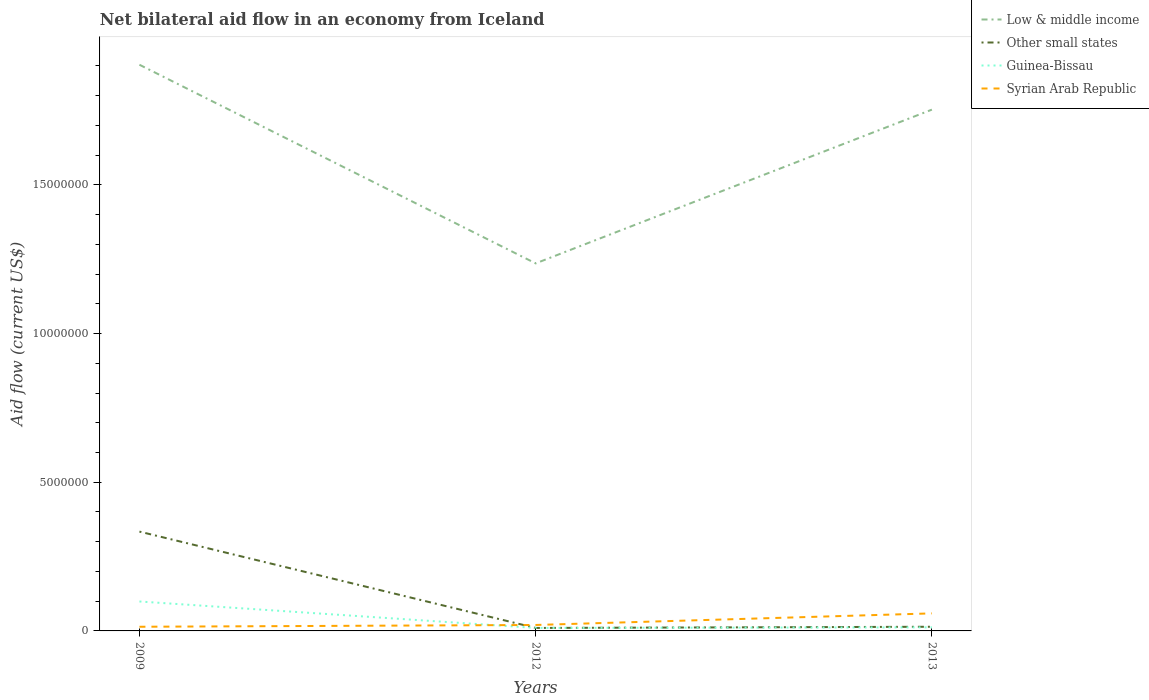How many different coloured lines are there?
Keep it short and to the point. 4. Is the number of lines equal to the number of legend labels?
Offer a very short reply. Yes. Across all years, what is the maximum net bilateral aid flow in Other small states?
Give a very brief answer. 1.00e+05. What is the total net bilateral aid flow in Guinea-Bissau in the graph?
Your response must be concise. 8.70e+05. What is the difference between the highest and the second highest net bilateral aid flow in Other small states?
Your answer should be very brief. 3.24e+06. Is the net bilateral aid flow in Syrian Arab Republic strictly greater than the net bilateral aid flow in Low & middle income over the years?
Offer a very short reply. Yes. How many lines are there?
Your response must be concise. 4. How many years are there in the graph?
Ensure brevity in your answer.  3. What is the title of the graph?
Give a very brief answer. Net bilateral aid flow in an economy from Iceland. Does "Bulgaria" appear as one of the legend labels in the graph?
Keep it short and to the point. No. What is the label or title of the Y-axis?
Your answer should be compact. Aid flow (current US$). What is the Aid flow (current US$) of Low & middle income in 2009?
Keep it short and to the point. 1.90e+07. What is the Aid flow (current US$) in Other small states in 2009?
Give a very brief answer. 3.34e+06. What is the Aid flow (current US$) in Guinea-Bissau in 2009?
Your answer should be very brief. 9.90e+05. What is the Aid flow (current US$) of Syrian Arab Republic in 2009?
Your answer should be very brief. 1.40e+05. What is the Aid flow (current US$) of Low & middle income in 2012?
Offer a terse response. 1.24e+07. What is the Aid flow (current US$) in Other small states in 2012?
Give a very brief answer. 1.00e+05. What is the Aid flow (current US$) in Syrian Arab Republic in 2012?
Your response must be concise. 2.00e+05. What is the Aid flow (current US$) of Low & middle income in 2013?
Your response must be concise. 1.75e+07. What is the Aid flow (current US$) in Guinea-Bissau in 2013?
Make the answer very short. 1.20e+05. What is the Aid flow (current US$) of Syrian Arab Republic in 2013?
Your response must be concise. 5.90e+05. Across all years, what is the maximum Aid flow (current US$) of Low & middle income?
Keep it short and to the point. 1.90e+07. Across all years, what is the maximum Aid flow (current US$) of Other small states?
Your answer should be very brief. 3.34e+06. Across all years, what is the maximum Aid flow (current US$) in Guinea-Bissau?
Your answer should be very brief. 9.90e+05. Across all years, what is the maximum Aid flow (current US$) of Syrian Arab Republic?
Your answer should be compact. 5.90e+05. Across all years, what is the minimum Aid flow (current US$) of Low & middle income?
Your answer should be compact. 1.24e+07. Across all years, what is the minimum Aid flow (current US$) of Other small states?
Keep it short and to the point. 1.00e+05. What is the total Aid flow (current US$) in Low & middle income in the graph?
Offer a terse response. 4.89e+07. What is the total Aid flow (current US$) in Other small states in the graph?
Your answer should be compact. 3.58e+06. What is the total Aid flow (current US$) in Guinea-Bissau in the graph?
Offer a very short reply. 1.21e+06. What is the total Aid flow (current US$) of Syrian Arab Republic in the graph?
Provide a short and direct response. 9.30e+05. What is the difference between the Aid flow (current US$) in Low & middle income in 2009 and that in 2012?
Provide a short and direct response. 6.68e+06. What is the difference between the Aid flow (current US$) in Other small states in 2009 and that in 2012?
Your answer should be compact. 3.24e+06. What is the difference between the Aid flow (current US$) of Guinea-Bissau in 2009 and that in 2012?
Offer a terse response. 8.90e+05. What is the difference between the Aid flow (current US$) in Syrian Arab Republic in 2009 and that in 2012?
Keep it short and to the point. -6.00e+04. What is the difference between the Aid flow (current US$) in Low & middle income in 2009 and that in 2013?
Provide a succinct answer. 1.51e+06. What is the difference between the Aid flow (current US$) of Other small states in 2009 and that in 2013?
Your answer should be very brief. 3.20e+06. What is the difference between the Aid flow (current US$) in Guinea-Bissau in 2009 and that in 2013?
Your response must be concise. 8.70e+05. What is the difference between the Aid flow (current US$) in Syrian Arab Republic in 2009 and that in 2013?
Make the answer very short. -4.50e+05. What is the difference between the Aid flow (current US$) in Low & middle income in 2012 and that in 2013?
Offer a very short reply. -5.17e+06. What is the difference between the Aid flow (current US$) in Syrian Arab Republic in 2012 and that in 2013?
Provide a succinct answer. -3.90e+05. What is the difference between the Aid flow (current US$) in Low & middle income in 2009 and the Aid flow (current US$) in Other small states in 2012?
Make the answer very short. 1.89e+07. What is the difference between the Aid flow (current US$) in Low & middle income in 2009 and the Aid flow (current US$) in Guinea-Bissau in 2012?
Your response must be concise. 1.89e+07. What is the difference between the Aid flow (current US$) of Low & middle income in 2009 and the Aid flow (current US$) of Syrian Arab Republic in 2012?
Offer a terse response. 1.88e+07. What is the difference between the Aid flow (current US$) of Other small states in 2009 and the Aid flow (current US$) of Guinea-Bissau in 2012?
Offer a very short reply. 3.24e+06. What is the difference between the Aid flow (current US$) in Other small states in 2009 and the Aid flow (current US$) in Syrian Arab Republic in 2012?
Your answer should be compact. 3.14e+06. What is the difference between the Aid flow (current US$) of Guinea-Bissau in 2009 and the Aid flow (current US$) of Syrian Arab Republic in 2012?
Offer a very short reply. 7.90e+05. What is the difference between the Aid flow (current US$) of Low & middle income in 2009 and the Aid flow (current US$) of Other small states in 2013?
Your answer should be very brief. 1.89e+07. What is the difference between the Aid flow (current US$) of Low & middle income in 2009 and the Aid flow (current US$) of Guinea-Bissau in 2013?
Provide a succinct answer. 1.89e+07. What is the difference between the Aid flow (current US$) of Low & middle income in 2009 and the Aid flow (current US$) of Syrian Arab Republic in 2013?
Offer a very short reply. 1.84e+07. What is the difference between the Aid flow (current US$) of Other small states in 2009 and the Aid flow (current US$) of Guinea-Bissau in 2013?
Your answer should be very brief. 3.22e+06. What is the difference between the Aid flow (current US$) in Other small states in 2009 and the Aid flow (current US$) in Syrian Arab Republic in 2013?
Provide a short and direct response. 2.75e+06. What is the difference between the Aid flow (current US$) of Guinea-Bissau in 2009 and the Aid flow (current US$) of Syrian Arab Republic in 2013?
Offer a very short reply. 4.00e+05. What is the difference between the Aid flow (current US$) of Low & middle income in 2012 and the Aid flow (current US$) of Other small states in 2013?
Keep it short and to the point. 1.22e+07. What is the difference between the Aid flow (current US$) in Low & middle income in 2012 and the Aid flow (current US$) in Guinea-Bissau in 2013?
Your answer should be very brief. 1.22e+07. What is the difference between the Aid flow (current US$) in Low & middle income in 2012 and the Aid flow (current US$) in Syrian Arab Republic in 2013?
Give a very brief answer. 1.18e+07. What is the difference between the Aid flow (current US$) of Other small states in 2012 and the Aid flow (current US$) of Syrian Arab Republic in 2013?
Keep it short and to the point. -4.90e+05. What is the difference between the Aid flow (current US$) of Guinea-Bissau in 2012 and the Aid flow (current US$) of Syrian Arab Republic in 2013?
Keep it short and to the point. -4.90e+05. What is the average Aid flow (current US$) in Low & middle income per year?
Make the answer very short. 1.63e+07. What is the average Aid flow (current US$) in Other small states per year?
Give a very brief answer. 1.19e+06. What is the average Aid flow (current US$) of Guinea-Bissau per year?
Your response must be concise. 4.03e+05. In the year 2009, what is the difference between the Aid flow (current US$) in Low & middle income and Aid flow (current US$) in Other small states?
Make the answer very short. 1.57e+07. In the year 2009, what is the difference between the Aid flow (current US$) in Low & middle income and Aid flow (current US$) in Guinea-Bissau?
Offer a terse response. 1.80e+07. In the year 2009, what is the difference between the Aid flow (current US$) in Low & middle income and Aid flow (current US$) in Syrian Arab Republic?
Offer a terse response. 1.89e+07. In the year 2009, what is the difference between the Aid flow (current US$) in Other small states and Aid flow (current US$) in Guinea-Bissau?
Offer a terse response. 2.35e+06. In the year 2009, what is the difference between the Aid flow (current US$) in Other small states and Aid flow (current US$) in Syrian Arab Republic?
Provide a short and direct response. 3.20e+06. In the year 2009, what is the difference between the Aid flow (current US$) of Guinea-Bissau and Aid flow (current US$) of Syrian Arab Republic?
Make the answer very short. 8.50e+05. In the year 2012, what is the difference between the Aid flow (current US$) in Low & middle income and Aid flow (current US$) in Other small states?
Offer a terse response. 1.23e+07. In the year 2012, what is the difference between the Aid flow (current US$) of Low & middle income and Aid flow (current US$) of Guinea-Bissau?
Keep it short and to the point. 1.23e+07. In the year 2012, what is the difference between the Aid flow (current US$) of Low & middle income and Aid flow (current US$) of Syrian Arab Republic?
Give a very brief answer. 1.22e+07. In the year 2012, what is the difference between the Aid flow (current US$) of Other small states and Aid flow (current US$) of Guinea-Bissau?
Ensure brevity in your answer.  0. In the year 2013, what is the difference between the Aid flow (current US$) of Low & middle income and Aid flow (current US$) of Other small states?
Ensure brevity in your answer.  1.74e+07. In the year 2013, what is the difference between the Aid flow (current US$) in Low & middle income and Aid flow (current US$) in Guinea-Bissau?
Your answer should be compact. 1.74e+07. In the year 2013, what is the difference between the Aid flow (current US$) in Low & middle income and Aid flow (current US$) in Syrian Arab Republic?
Give a very brief answer. 1.69e+07. In the year 2013, what is the difference between the Aid flow (current US$) of Other small states and Aid flow (current US$) of Guinea-Bissau?
Keep it short and to the point. 2.00e+04. In the year 2013, what is the difference between the Aid flow (current US$) of Other small states and Aid flow (current US$) of Syrian Arab Republic?
Your answer should be compact. -4.50e+05. In the year 2013, what is the difference between the Aid flow (current US$) in Guinea-Bissau and Aid flow (current US$) in Syrian Arab Republic?
Give a very brief answer. -4.70e+05. What is the ratio of the Aid flow (current US$) in Low & middle income in 2009 to that in 2012?
Provide a short and direct response. 1.54. What is the ratio of the Aid flow (current US$) in Other small states in 2009 to that in 2012?
Provide a short and direct response. 33.4. What is the ratio of the Aid flow (current US$) in Guinea-Bissau in 2009 to that in 2012?
Your response must be concise. 9.9. What is the ratio of the Aid flow (current US$) in Low & middle income in 2009 to that in 2013?
Make the answer very short. 1.09. What is the ratio of the Aid flow (current US$) of Other small states in 2009 to that in 2013?
Your answer should be compact. 23.86. What is the ratio of the Aid flow (current US$) in Guinea-Bissau in 2009 to that in 2013?
Give a very brief answer. 8.25. What is the ratio of the Aid flow (current US$) in Syrian Arab Republic in 2009 to that in 2013?
Your answer should be compact. 0.24. What is the ratio of the Aid flow (current US$) of Low & middle income in 2012 to that in 2013?
Keep it short and to the point. 0.71. What is the ratio of the Aid flow (current US$) of Syrian Arab Republic in 2012 to that in 2013?
Offer a terse response. 0.34. What is the difference between the highest and the second highest Aid flow (current US$) of Low & middle income?
Your answer should be very brief. 1.51e+06. What is the difference between the highest and the second highest Aid flow (current US$) of Other small states?
Your answer should be very brief. 3.20e+06. What is the difference between the highest and the second highest Aid flow (current US$) in Guinea-Bissau?
Ensure brevity in your answer.  8.70e+05. What is the difference between the highest and the second highest Aid flow (current US$) of Syrian Arab Republic?
Ensure brevity in your answer.  3.90e+05. What is the difference between the highest and the lowest Aid flow (current US$) of Low & middle income?
Offer a very short reply. 6.68e+06. What is the difference between the highest and the lowest Aid flow (current US$) of Other small states?
Your response must be concise. 3.24e+06. What is the difference between the highest and the lowest Aid flow (current US$) in Guinea-Bissau?
Keep it short and to the point. 8.90e+05. What is the difference between the highest and the lowest Aid flow (current US$) of Syrian Arab Republic?
Offer a terse response. 4.50e+05. 